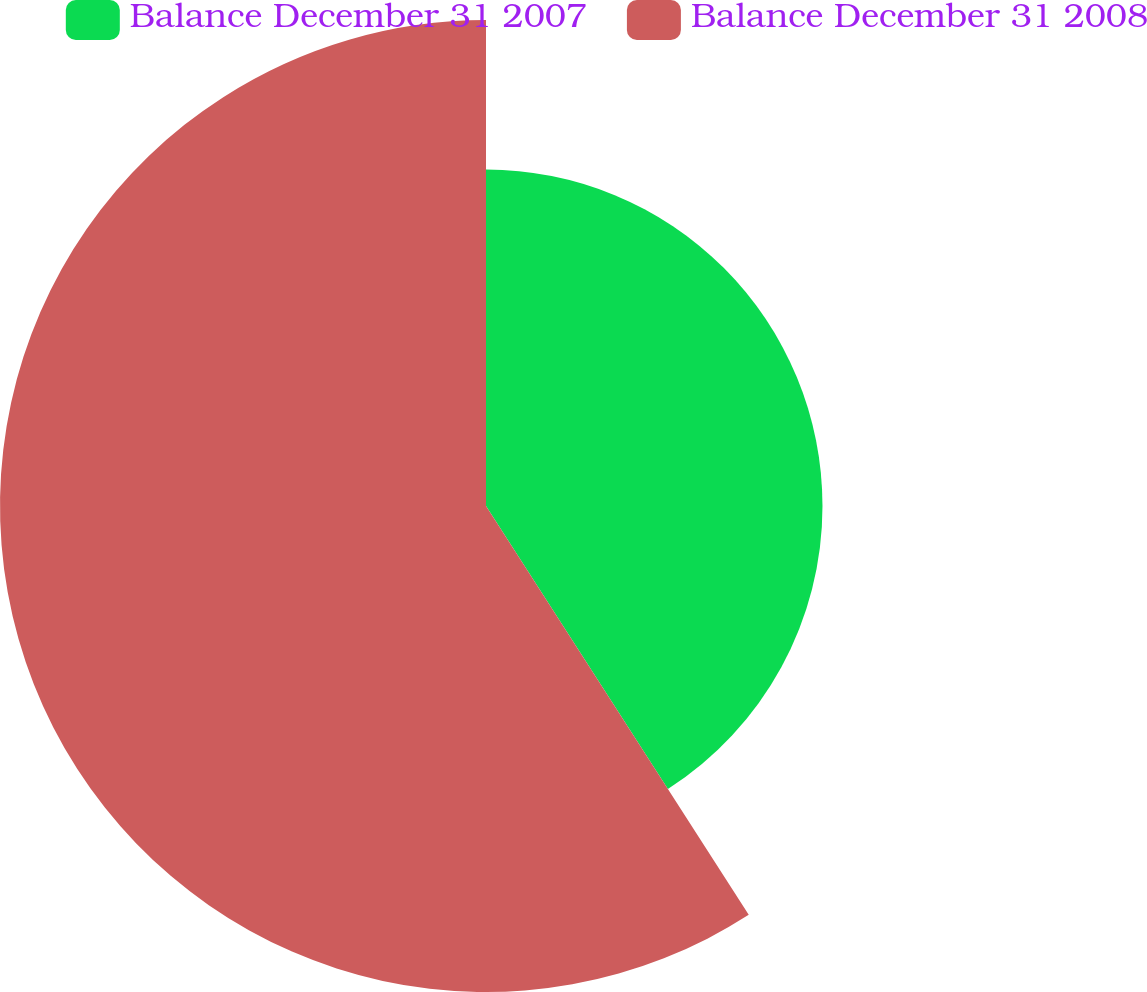Convert chart to OTSL. <chart><loc_0><loc_0><loc_500><loc_500><pie_chart><fcel>Balance December 31 2007<fcel>Balance December 31 2008<nl><fcel>40.91%<fcel>59.09%<nl></chart> 